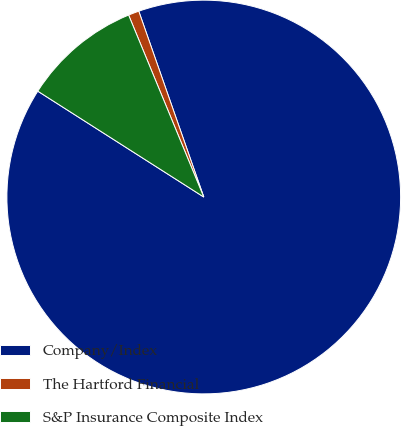Convert chart. <chart><loc_0><loc_0><loc_500><loc_500><pie_chart><fcel>Company/Index<fcel>The Hartford Financial<fcel>S&P Insurance Composite Index<nl><fcel>89.39%<fcel>0.88%<fcel>9.73%<nl></chart> 